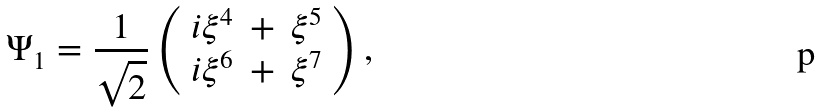<formula> <loc_0><loc_0><loc_500><loc_500>\Psi _ { 1 } = \frac { 1 } { \sqrt { 2 } } \left ( \begin{array} { r c l } i \xi ^ { 4 } & + & \xi ^ { 5 } \\ i \xi ^ { 6 } & + & \xi ^ { 7 } \end{array} \right ) ,</formula> 